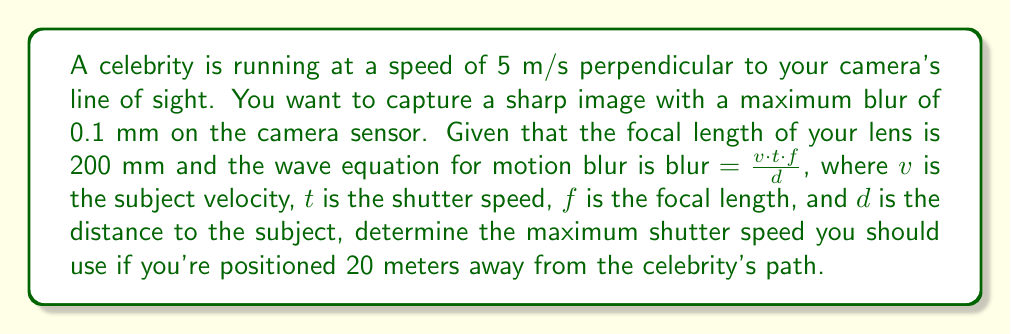Can you solve this math problem? To solve this problem, we'll use the wave equation for motion blur and solve for the shutter speed $t$:

$$\text{blur} = \frac{v \cdot t \cdot f}{d}$$

We're given:
- $v = 5$ m/s (celebrity's speed)
- $\text{blur} = 0.1$ mm = $0.0001$ m (maximum allowable blur)
- $f = 200$ mm = $0.2$ m (focal length)
- $d = 20$ m (distance to subject)

Let's rearrange the equation to solve for $t$:

$$t = \frac{\text{blur} \cdot d}{v \cdot f}$$

Now, let's substitute the values:

$$t = \frac{0.0001 \text{ m} \cdot 20 \text{ m}}{5 \text{ m/s} \cdot 0.2 \text{ m}}$$

$$t = \frac{0.002}{1} = 0.002 \text{ s}$$

Converting to a more practical unit:

$$t = 0.002 \text{ s} = 1/500 \text{ s}$$

Therefore, the maximum shutter speed you should use is 1/500 second to ensure the motion blur doesn't exceed 0.1 mm on the sensor.
Answer: 1/500 s 